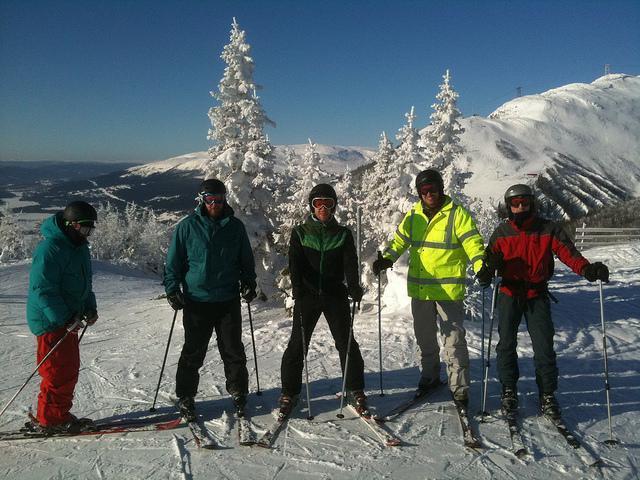How many people in the image are wearing blue?
Give a very brief answer. 2. How many people are shown?
Give a very brief answer. 5. How many people are there?
Give a very brief answer. 5. 